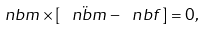Convert formula to latex. <formula><loc_0><loc_0><loc_500><loc_500>\ n b m \times [ \, \ddot { \ n b m } - { \ n b f } \, ] = 0 ,</formula> 